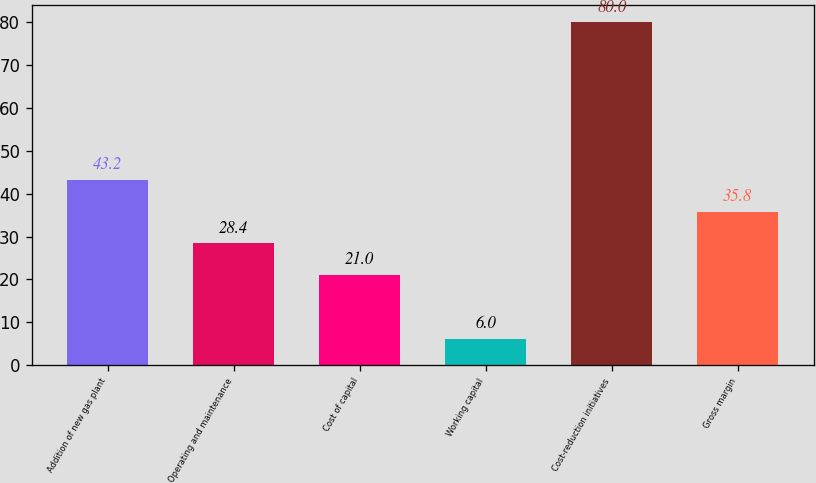Convert chart. <chart><loc_0><loc_0><loc_500><loc_500><bar_chart><fcel>Addition of new gas plant<fcel>Operating and maintenance<fcel>Cost of capital<fcel>Working capital<fcel>Cost-reduction initiatives<fcel>Gross margin<nl><fcel>43.2<fcel>28.4<fcel>21<fcel>6<fcel>80<fcel>35.8<nl></chart> 